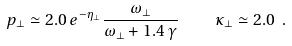<formula> <loc_0><loc_0><loc_500><loc_500>p _ { \bot } \simeq 2 . 0 \, e ^ { - \eta _ { \bot } } \frac { \omega _ { \bot } } { \omega _ { \bot } + 1 . 4 \, \gamma } \quad \kappa _ { \bot } \simeq 2 . 0 \ .</formula> 